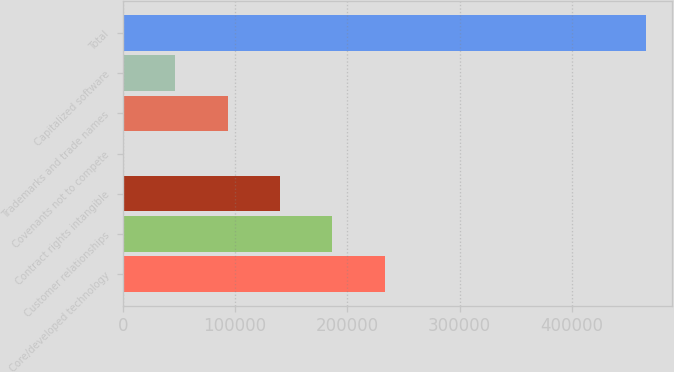Convert chart. <chart><loc_0><loc_0><loc_500><loc_500><bar_chart><fcel>Core/developed technology<fcel>Customer relationships<fcel>Contract rights intangible<fcel>Covenants not to compete<fcel>Trademarks and trade names<fcel>Capitalized software<fcel>Total<nl><fcel>233249<fcel>186634<fcel>140020<fcel>176<fcel>93405.2<fcel>46790.6<fcel>466322<nl></chart> 